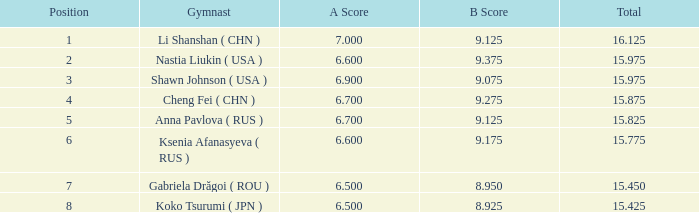What is the combined total for positions having a value below 1? None. Give me the full table as a dictionary. {'header': ['Position', 'Gymnast', 'A Score', 'B Score', 'Total'], 'rows': [['1', 'Li Shanshan ( CHN )', '7.000', '9.125', '16.125'], ['2', 'Nastia Liukin ( USA )', '6.600', '9.375', '15.975'], ['3', 'Shawn Johnson ( USA )', '6.900', '9.075', '15.975'], ['4', 'Cheng Fei ( CHN )', '6.700', '9.275', '15.875'], ['5', 'Anna Pavlova ( RUS )', '6.700', '9.125', '15.825'], ['6', 'Ksenia Afanasyeva ( RUS )', '6.600', '9.175', '15.775'], ['7', 'Gabriela Drăgoi ( ROU )', '6.500', '8.950', '15.450'], ['8', 'Koko Tsurumi ( JPN )', '6.500', '8.925', '15.425']]} 